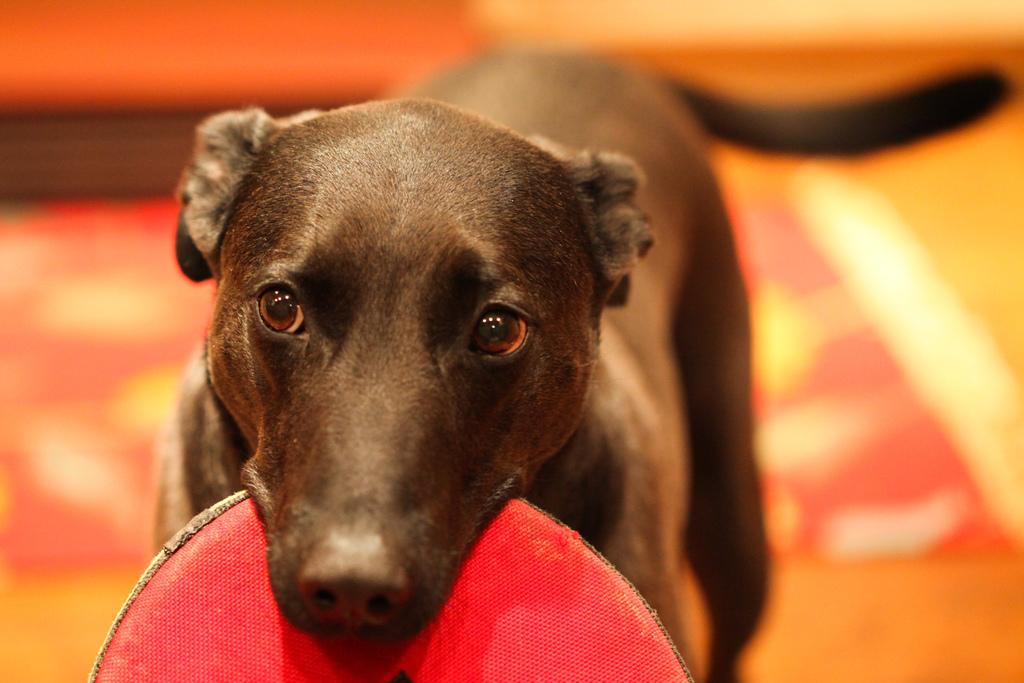What type of animal is in the image? There is a black dog in the image. What is the dog doing in the image? The dog is holding a disc in its mouth. Can you describe the background of the image? The background of the image is blurry. What type of worm can be seen crawling on the dog's back in the image? There is no worm present on the dog's back in the image. 